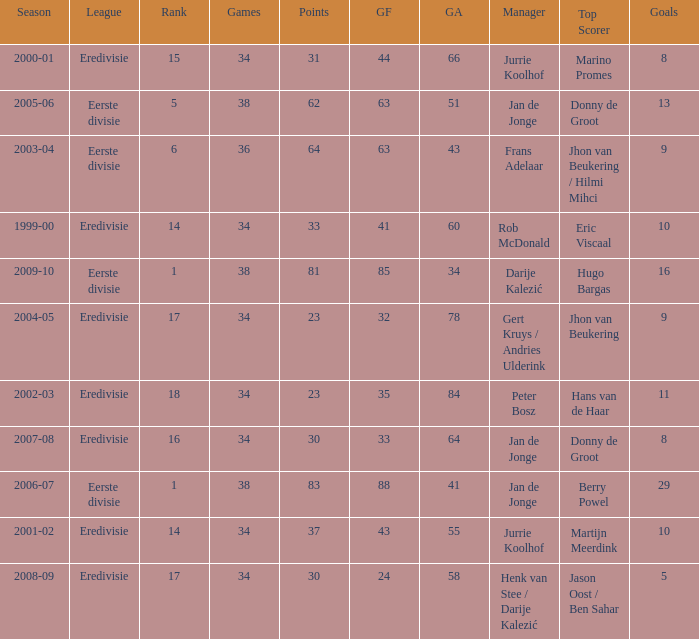What is the rank of manager Rob Mcdonald? 1.0. 